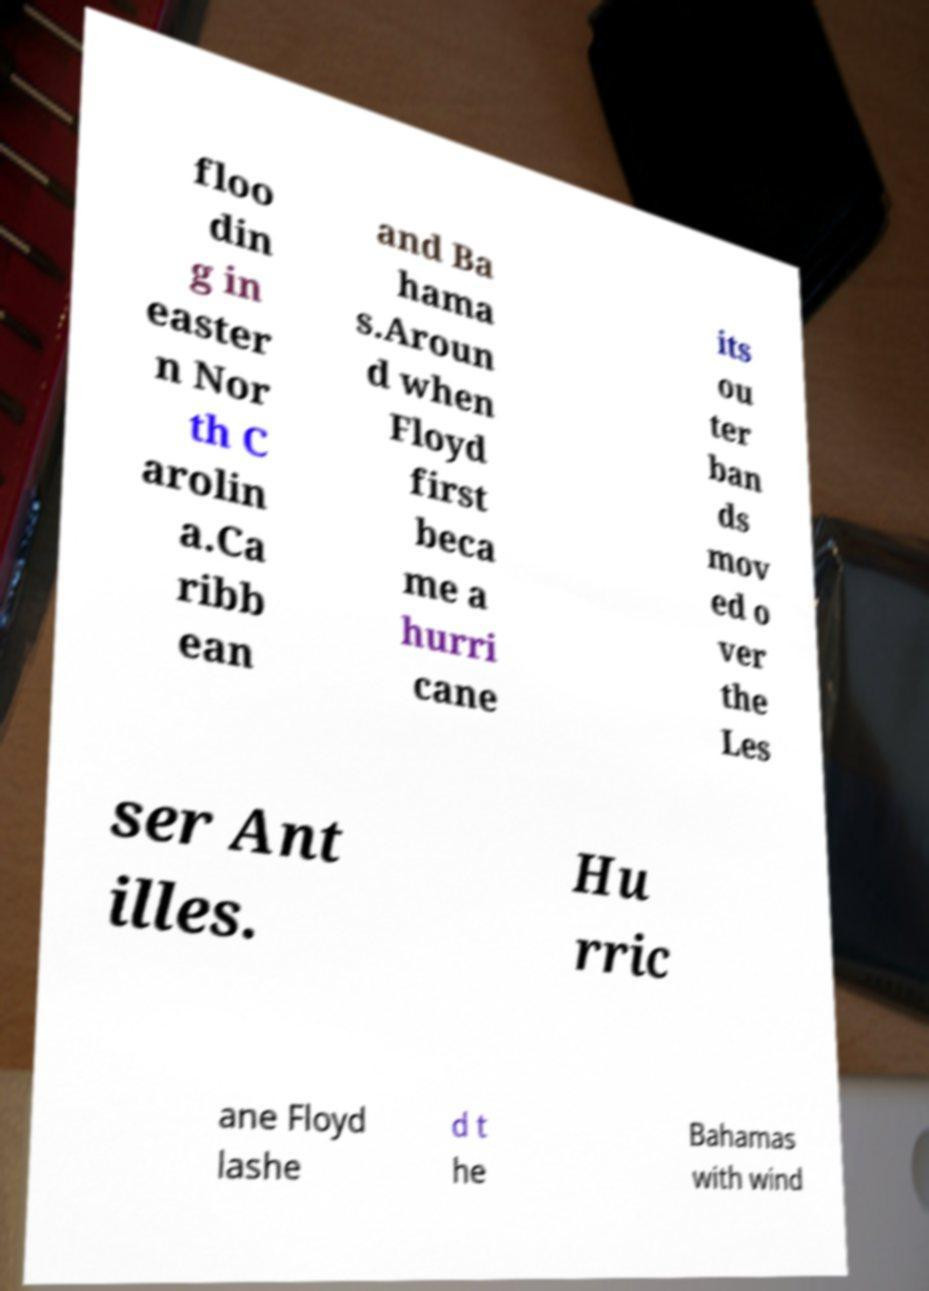Could you extract and type out the text from this image? floo din g in easter n Nor th C arolin a.Ca ribb ean and Ba hama s.Aroun d when Floyd first beca me a hurri cane its ou ter ban ds mov ed o ver the Les ser Ant illes. Hu rric ane Floyd lashe d t he Bahamas with wind 